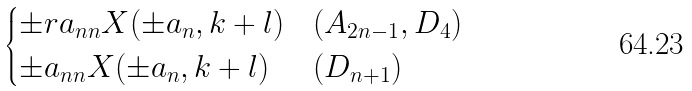Convert formula to latex. <formula><loc_0><loc_0><loc_500><loc_500>\begin{cases} \pm r a _ { n n } X ( \pm a _ { n } , k + l ) & ( A _ { 2 n - 1 } , D _ { 4 } ) \\ \pm a _ { n n } X ( \pm a _ { n } , k + l ) & ( D _ { n + 1 } ) \end{cases}</formula> 